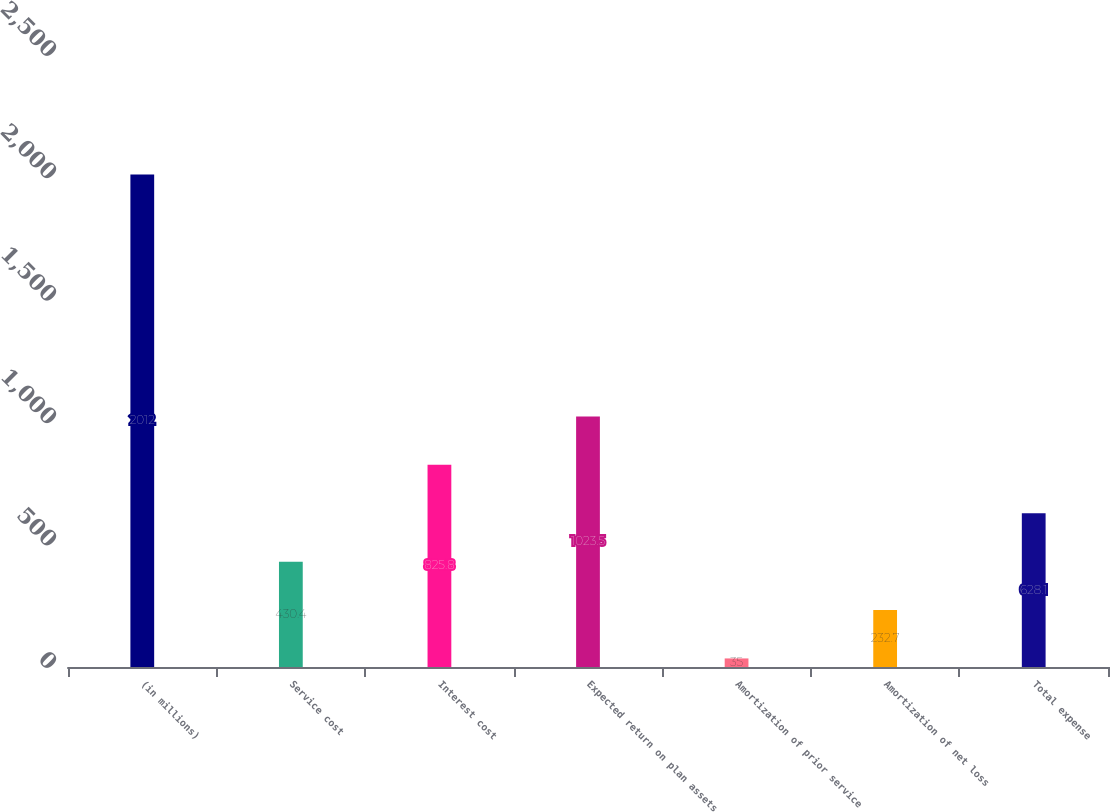Convert chart to OTSL. <chart><loc_0><loc_0><loc_500><loc_500><bar_chart><fcel>(in millions)<fcel>Service cost<fcel>Interest cost<fcel>Expected return on plan assets<fcel>Amortization of prior service<fcel>Amortization of net loss<fcel>Total expense<nl><fcel>2012<fcel>430.4<fcel>825.8<fcel>1023.5<fcel>35<fcel>232.7<fcel>628.1<nl></chart> 